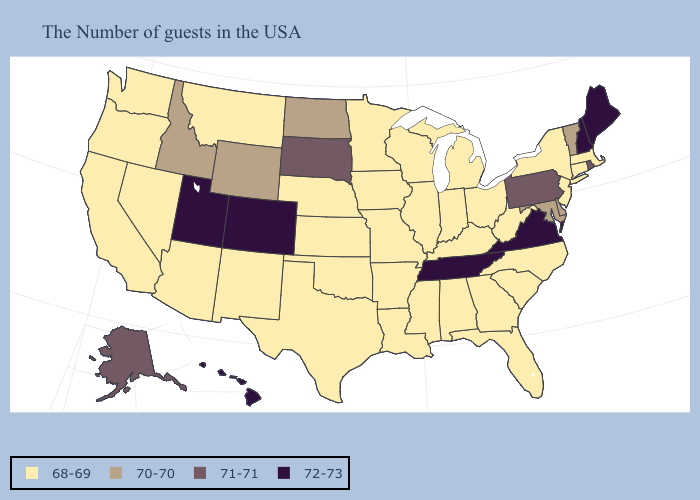Name the states that have a value in the range 70-70?
Write a very short answer. Vermont, Delaware, Maryland, North Dakota, Wyoming, Idaho. Which states hav the highest value in the MidWest?
Quick response, please. South Dakota. Does Maine have the highest value in the Northeast?
Short answer required. Yes. What is the value of Maine?
Keep it brief. 72-73. Which states have the lowest value in the USA?
Write a very short answer. Massachusetts, Connecticut, New York, New Jersey, North Carolina, South Carolina, West Virginia, Ohio, Florida, Georgia, Michigan, Kentucky, Indiana, Alabama, Wisconsin, Illinois, Mississippi, Louisiana, Missouri, Arkansas, Minnesota, Iowa, Kansas, Nebraska, Oklahoma, Texas, New Mexico, Montana, Arizona, Nevada, California, Washington, Oregon. Among the states that border Georgia , which have the lowest value?
Answer briefly. North Carolina, South Carolina, Florida, Alabama. Which states have the lowest value in the MidWest?
Quick response, please. Ohio, Michigan, Indiana, Wisconsin, Illinois, Missouri, Minnesota, Iowa, Kansas, Nebraska. Name the states that have a value in the range 71-71?
Answer briefly. Rhode Island, Pennsylvania, South Dakota, Alaska. Does Utah have a higher value than New Hampshire?
Concise answer only. No. What is the value of New Mexico?
Keep it brief. 68-69. Name the states that have a value in the range 71-71?
Answer briefly. Rhode Island, Pennsylvania, South Dakota, Alaska. Name the states that have a value in the range 72-73?
Keep it brief. Maine, New Hampshire, Virginia, Tennessee, Colorado, Utah, Hawaii. What is the value of Louisiana?
Answer briefly. 68-69. What is the value of Tennessee?
Short answer required. 72-73. Which states have the highest value in the USA?
Concise answer only. Maine, New Hampshire, Virginia, Tennessee, Colorado, Utah, Hawaii. 